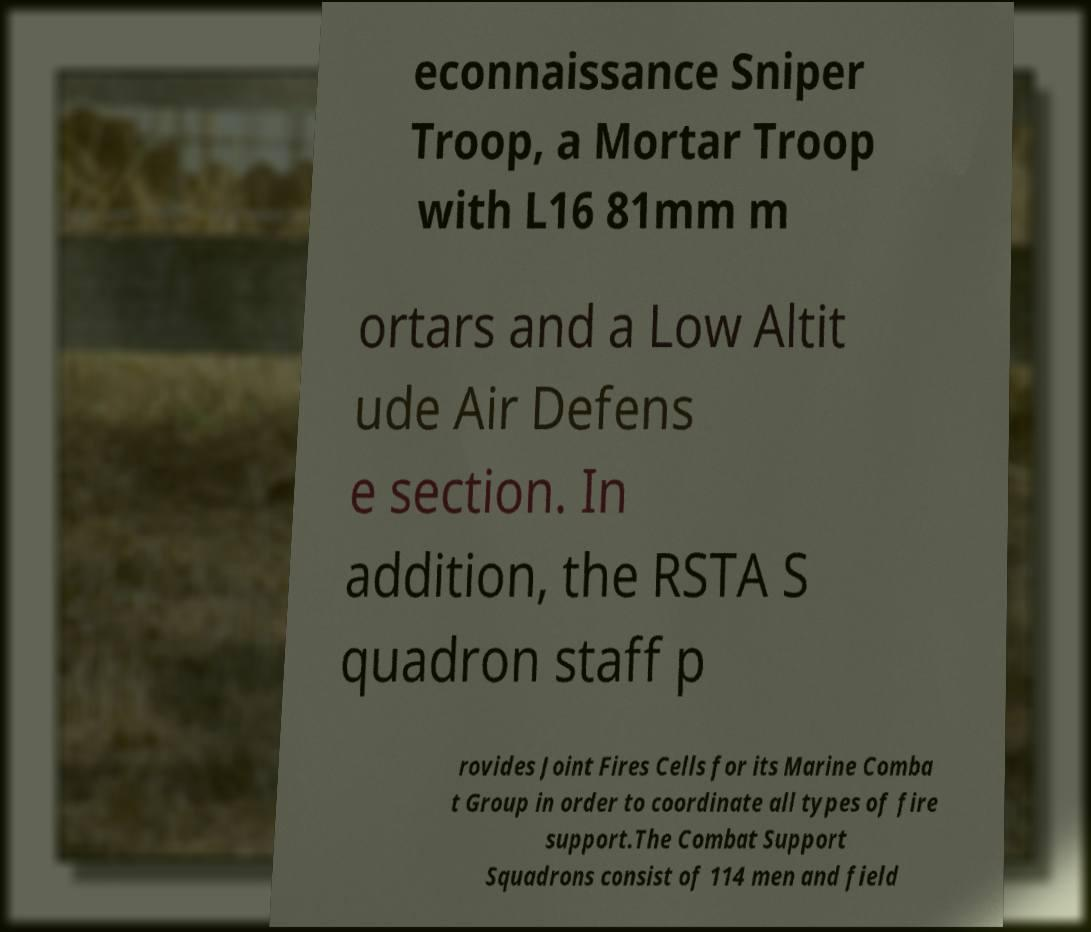I need the written content from this picture converted into text. Can you do that? econnaissance Sniper Troop, a Mortar Troop with L16 81mm m ortars and a Low Altit ude Air Defens e section. In addition, the RSTA S quadron staff p rovides Joint Fires Cells for its Marine Comba t Group in order to coordinate all types of fire support.The Combat Support Squadrons consist of 114 men and field 